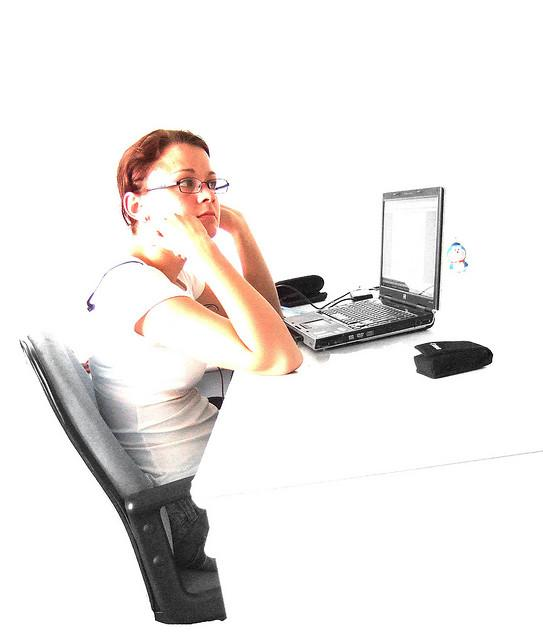Why is the woman sitting down? Please explain your reasoning. to work. The laptop implies this, but they could be waiting for food in b as well. 